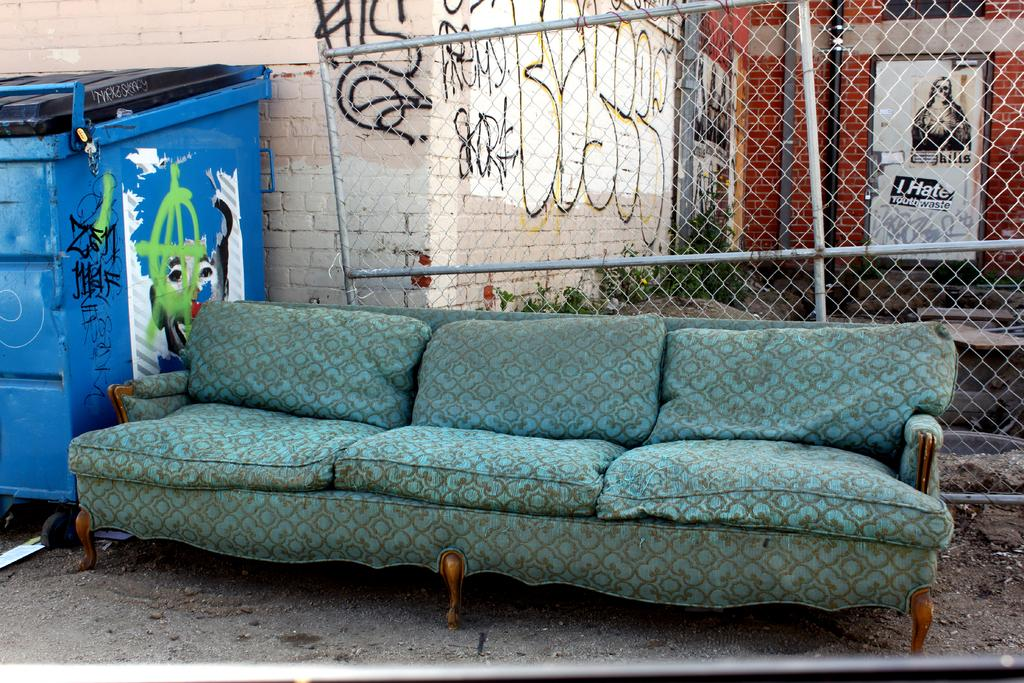What type of furniture is present in the image? There is a sofa in the image. What kind of barrier can be seen in the image? There is a fence in the image. What object is located on the left side of the image? There is a box on the left side of the image. What type of establishment is visible on the right side of the image? There is a shop on the right side of the image. What type of cup is being used to smell the fiction in the image? There is no cup or fiction present in the image. 